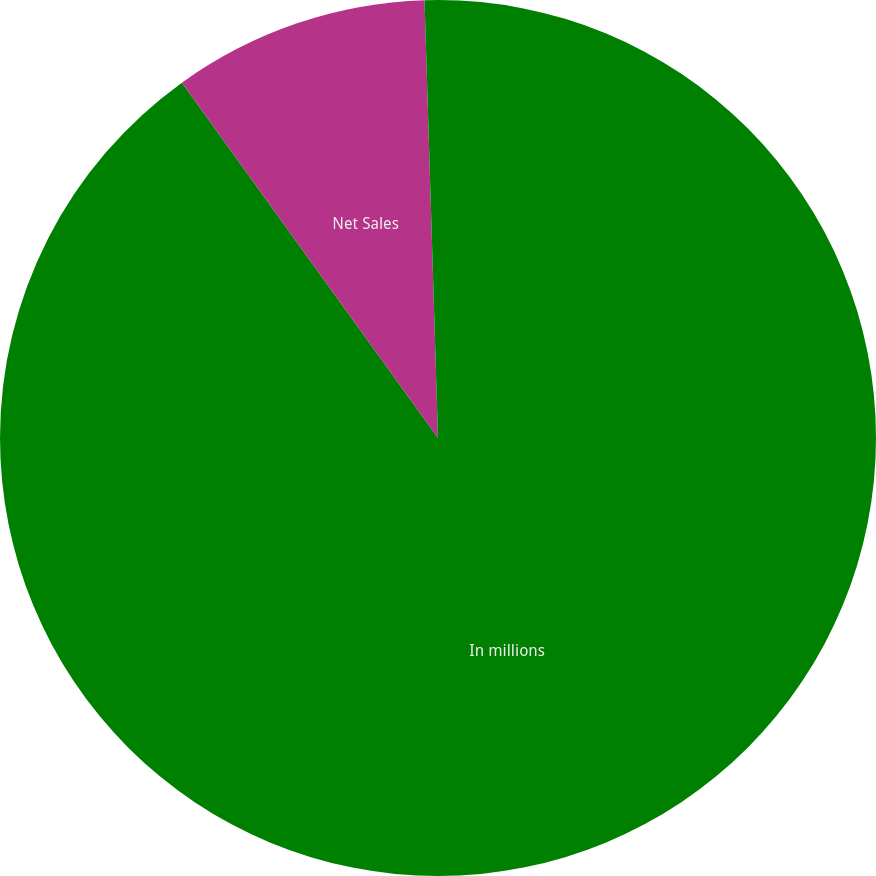Convert chart. <chart><loc_0><loc_0><loc_500><loc_500><pie_chart><fcel>In millions<fcel>Net Sales<fcel>Operating Profit (Loss)<nl><fcel>90.06%<fcel>9.45%<fcel>0.49%<nl></chart> 